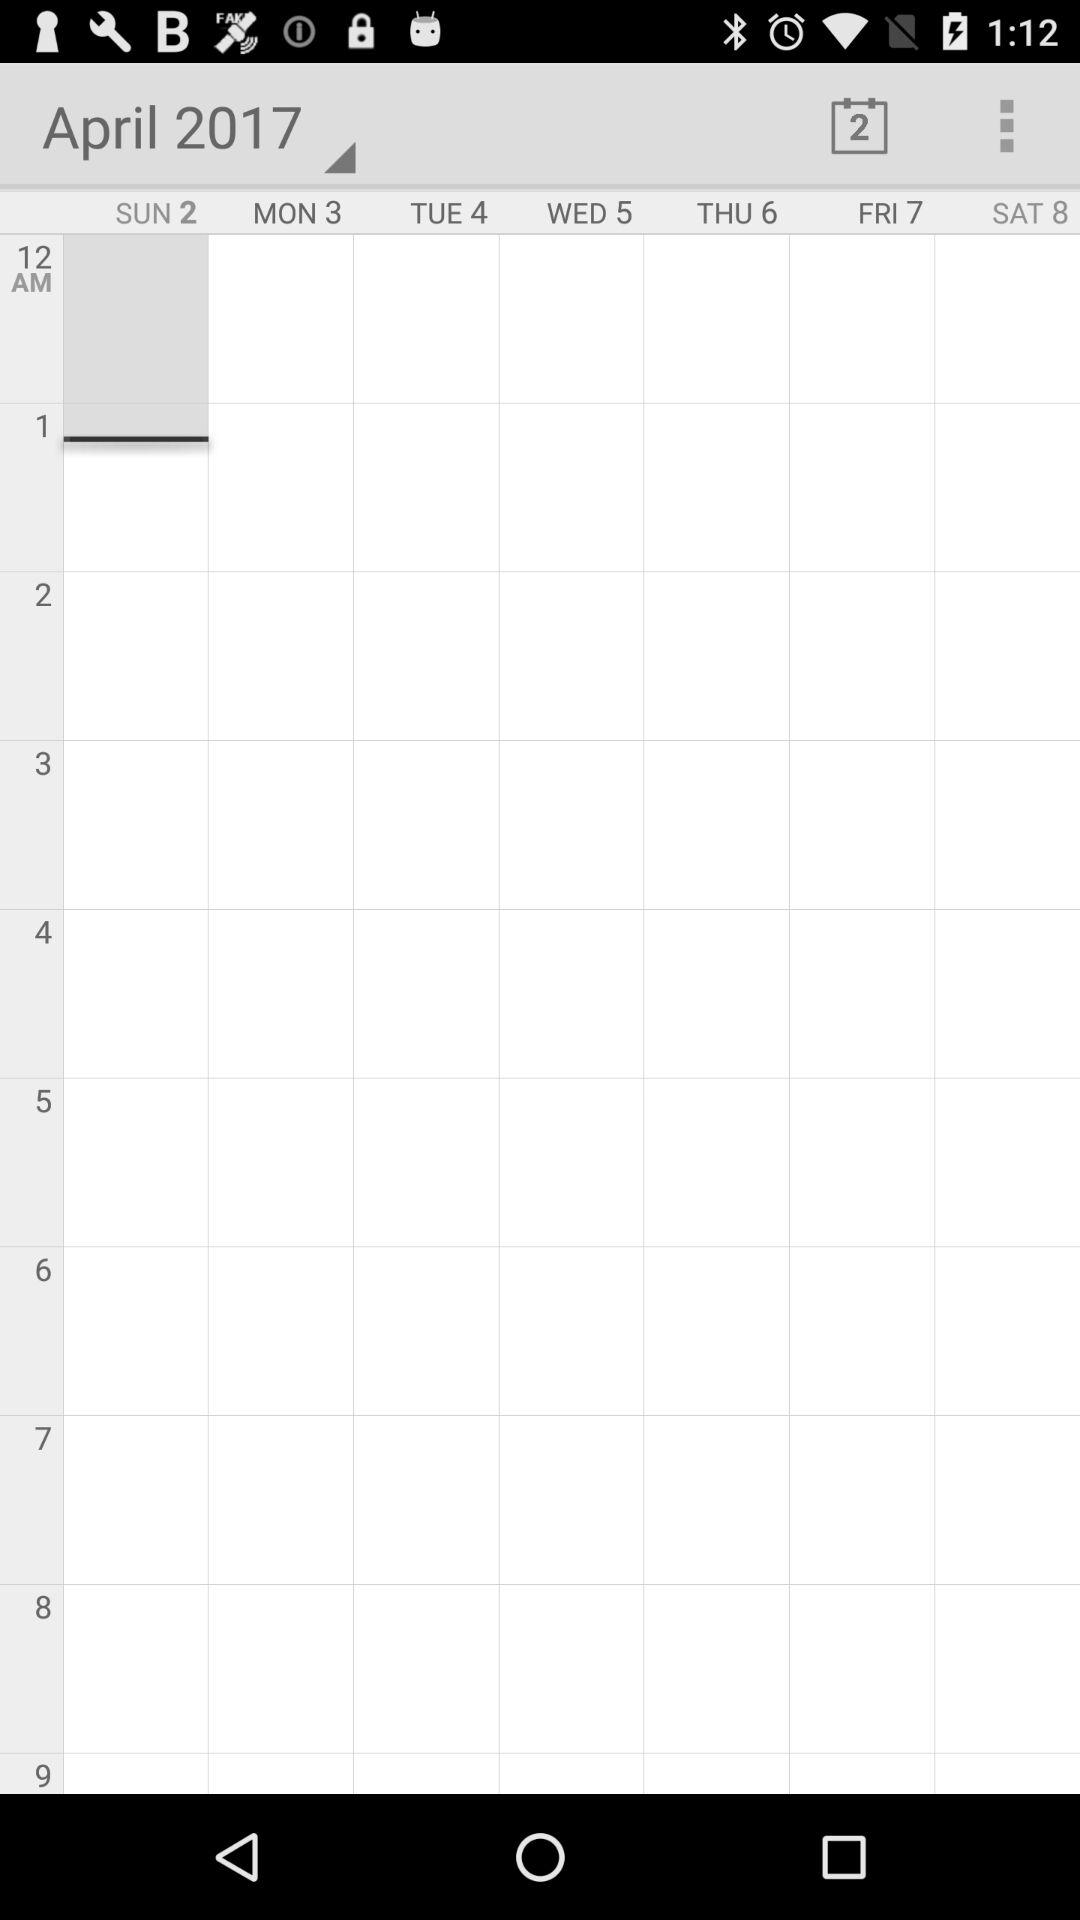Which month is it?
Answer the question using a single word or phrase. It is April. 